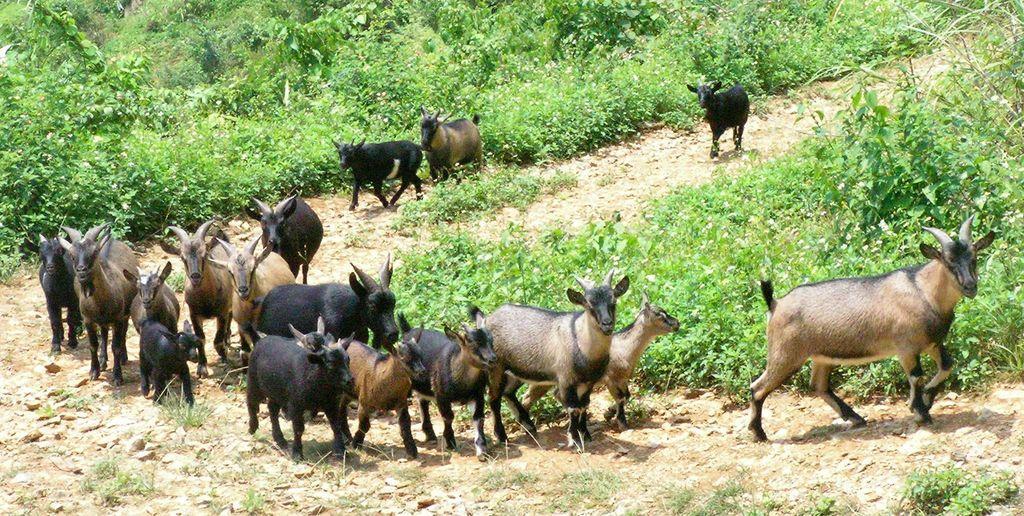How would you summarize this image in a sentence or two? In this picture we can see there are animals, plants and trees. 